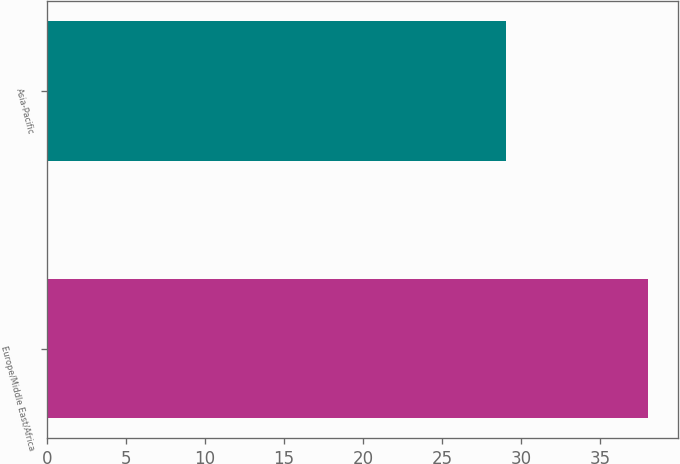<chart> <loc_0><loc_0><loc_500><loc_500><bar_chart><fcel>Europe/Middle East/Africa<fcel>Asia-Pacific<nl><fcel>38<fcel>29<nl></chart> 